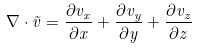<formula> <loc_0><loc_0><loc_500><loc_500>\nabla \cdot { \vec { v } } = { \frac { \partial v _ { x } } { \partial x } } + { \frac { \partial v _ { y } } { \partial y } } + { \frac { \partial v _ { z } } { \partial z } }</formula> 